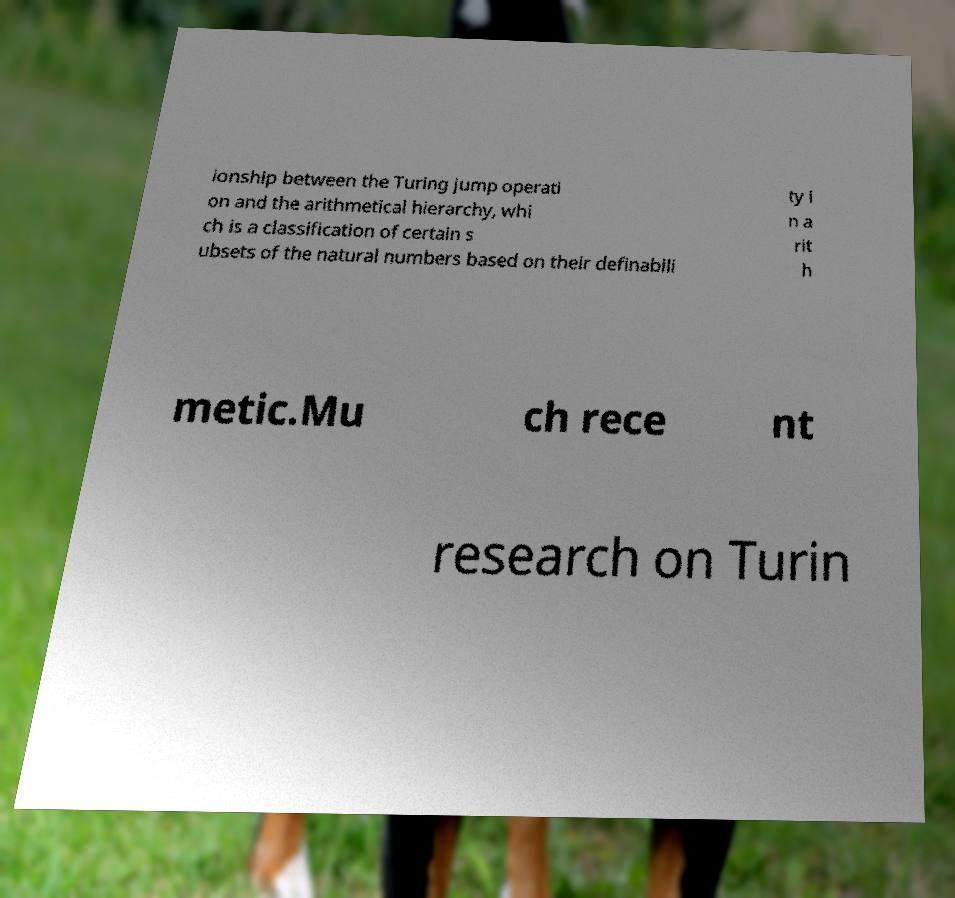Could you extract and type out the text from this image? ionship between the Turing jump operati on and the arithmetical hierarchy, whi ch is a classification of certain s ubsets of the natural numbers based on their definabili ty i n a rit h metic.Mu ch rece nt research on Turin 